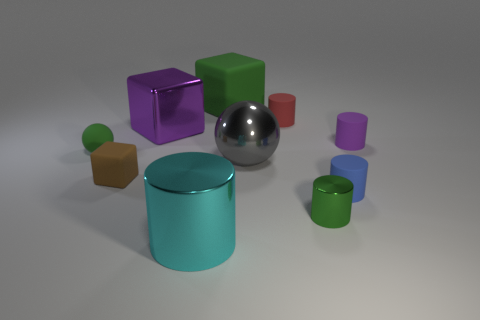Subtract all rubber cubes. How many cubes are left? 1 Subtract all red cylinders. How many cylinders are left? 4 Subtract all balls. How many objects are left? 8 Subtract all small brown things. Subtract all matte balls. How many objects are left? 8 Add 5 green cylinders. How many green cylinders are left? 6 Add 5 purple matte objects. How many purple matte objects exist? 6 Subtract 1 blue cylinders. How many objects are left? 9 Subtract 1 spheres. How many spheres are left? 1 Subtract all green cylinders. Subtract all cyan spheres. How many cylinders are left? 4 